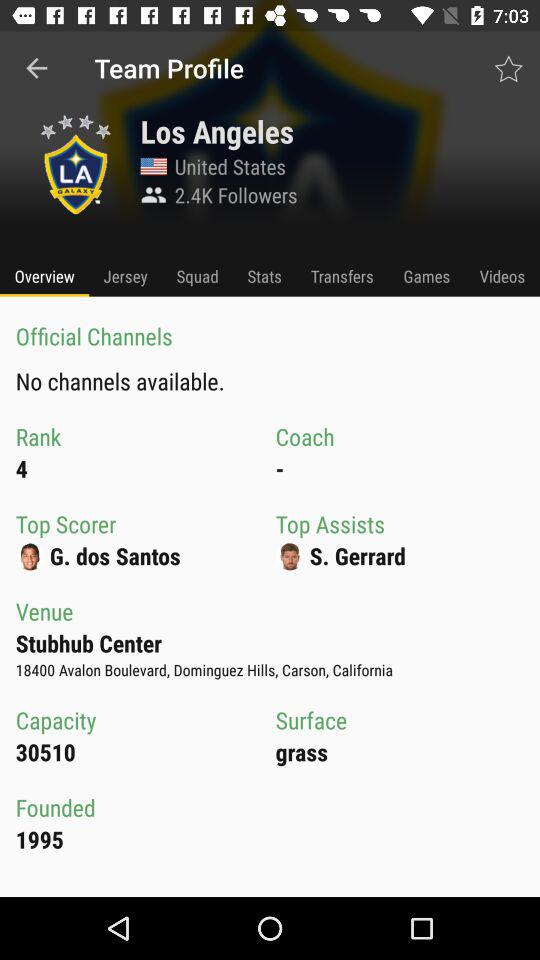Who is the top scorer? The top scorer is G. dos Santos. 